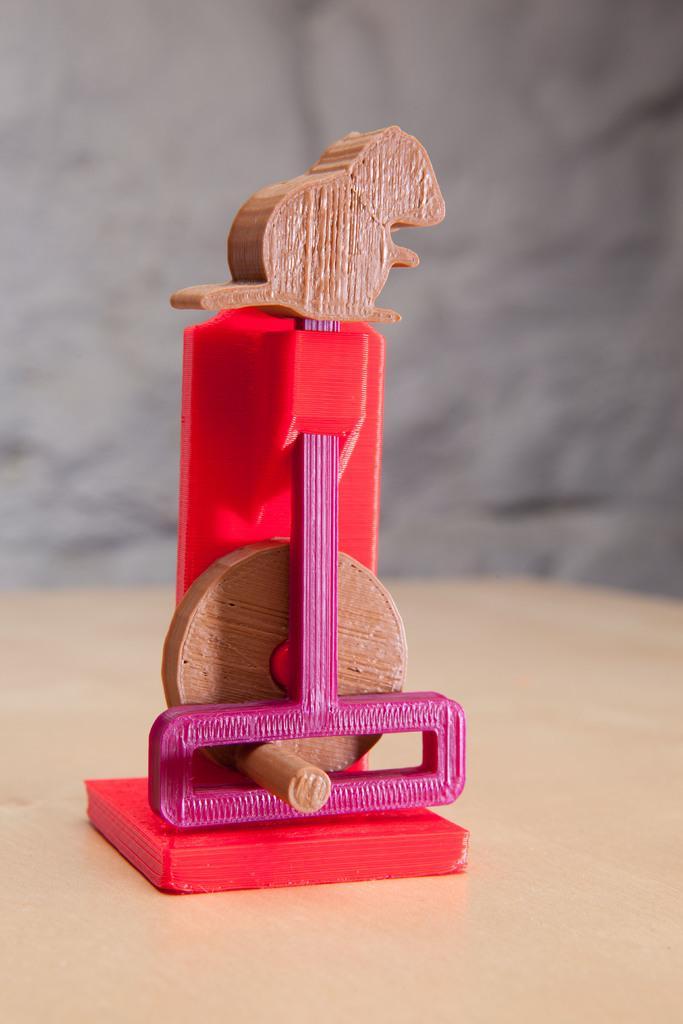Could you give a brief overview of what you see in this image? In the image I can see a wooden object which is in the rat shape at the top. 